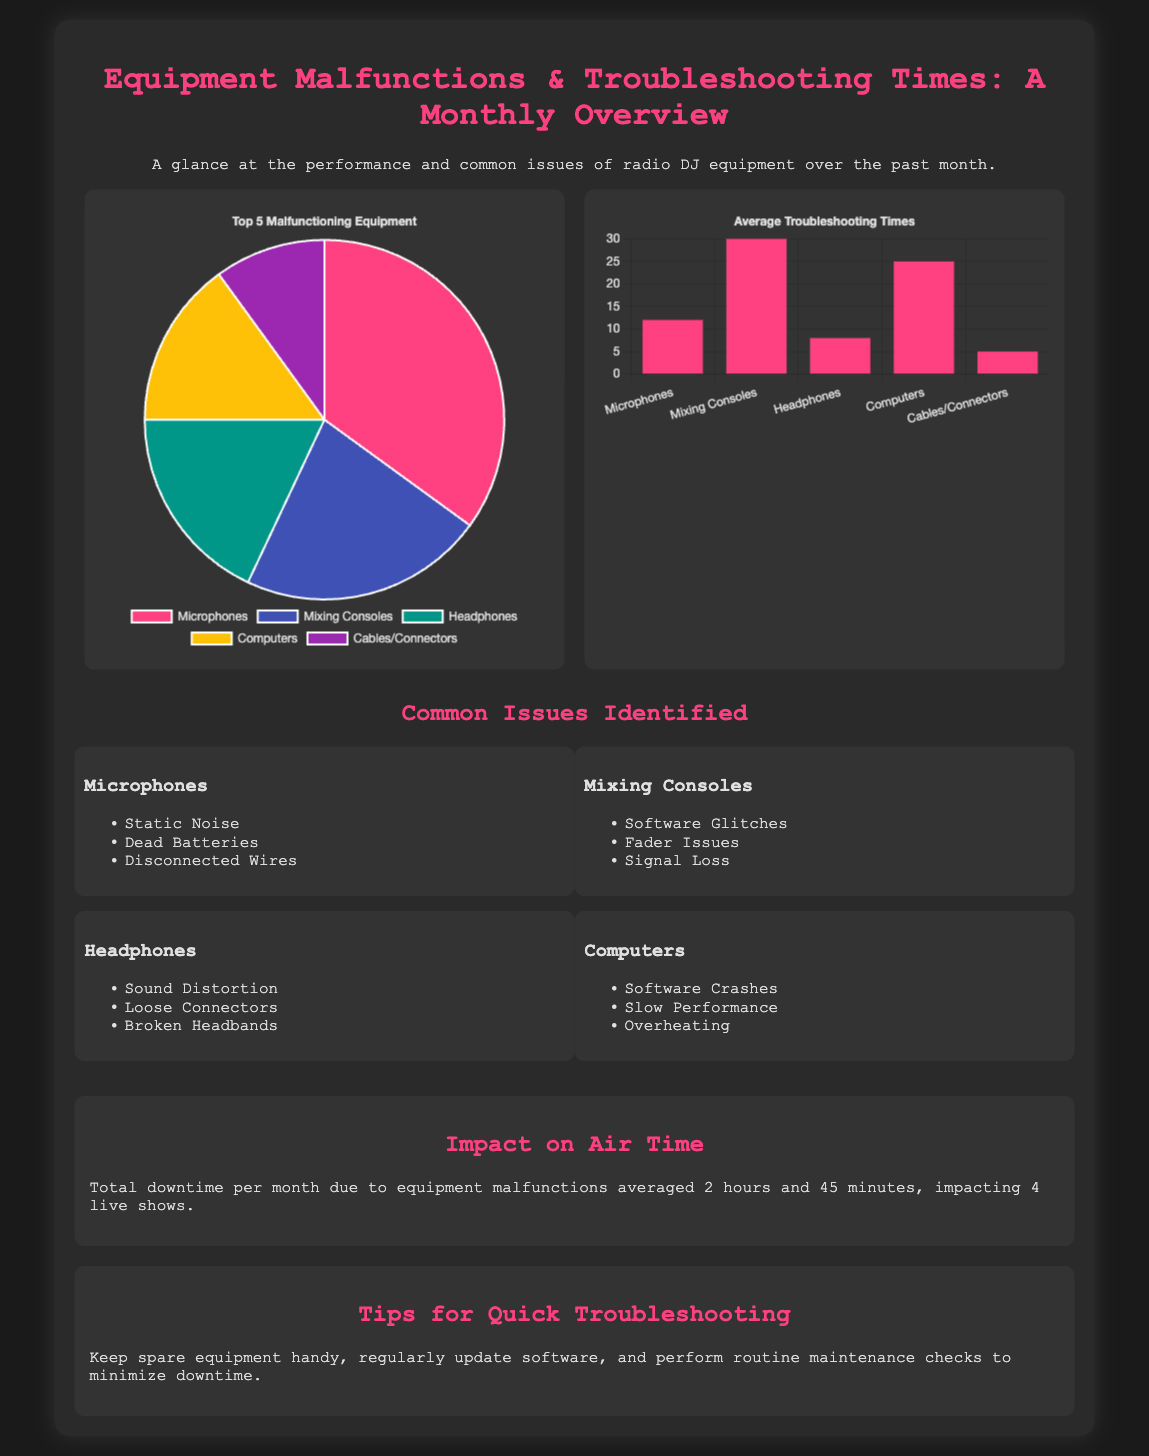What is the title of the document? The title appears at the top of the document and provides a summary of the content related to equipment malfunctions and troubleshooting times.
Answer: Equipment Malfunctions & Troubleshooting Times: A Monthly Overview How many live shows were impacted by equipment downtime? The document specifies the number of live shows affected by the downtime due to equipment issues.
Answer: 4 live shows What percentage of malfunctioning equipment does microphones represent? The infographic includes a pie chart showing the distribution of malfunctions, where the percentage for microphones is given directly.
Answer: 35% How many minutes is the average troubleshooting time for computers? The bar chart in the document reveals the average troubleshooting times for each equipment, specifically for computers.
Answer: 25 minutes What are the top two common issues listed for mixing consoles? The list of issues for mixing consoles includes several specific common problems, with the top two listed in the document.
Answer: Software Glitches, Fader Issues What impact did the equipment malfunctions have on downtime per month? The total downtime due to malfunctions is detailed in the document, providing a clear quantification of the impact.
Answer: 2 hours and 45 minutes Which equipment type has the least troubleshooting time? The bar chart presents the average troubleshooting times for various equipment, indicating which one has the least time required.
Answer: Cables/Connectors What is suggested for minimizing downtime? The tips section provides guidance on actions that can be taken to reduce equipment downtime in the studio, which is clearly outlined.
Answer: Keep spare equipment handy 